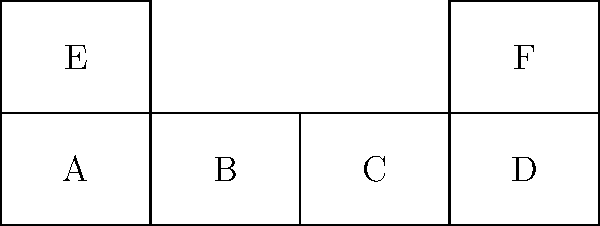The diagram shows an unfolded pattern for a makeup brush holder. When folded along the dashed lines, which two faces will be directly opposite each other in the final 3D shape? To determine which faces will be opposite each other in the final 3D shape, let's follow these steps:

1. Identify the base of the holder:
   Face A will form the base of the holder.

2. Visualize the folding process:
   - Faces B, C, and D will fold up to form the sides of the holder.
   - Faces E and F will fold up to form the ends of the holder.

3. Analyze the resulting 3D shape:
   - Face A (base) will be opposite the open top of the holder.
   - Faces B and D will be parallel to each other on opposite sides.
   - Faces E and F will be parallel to each other on opposite ends.

4. Identify the directly opposite faces:
   Among the labeled faces, E and F will be directly opposite each other in the final 3D shape.
Answer: E and F 